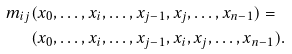Convert formula to latex. <formula><loc_0><loc_0><loc_500><loc_500>m _ { i j } & ( x _ { 0 } , \dots , x _ { i } , \dots , x _ { j - 1 } , x _ { j } , \dots , x _ { n - 1 } ) = \\ & ( x _ { 0 } , \dots , x _ { i } , \dots , x _ { j - 1 } , x _ { i } , x _ { j } , \dots , x _ { n - 1 } ) .</formula> 